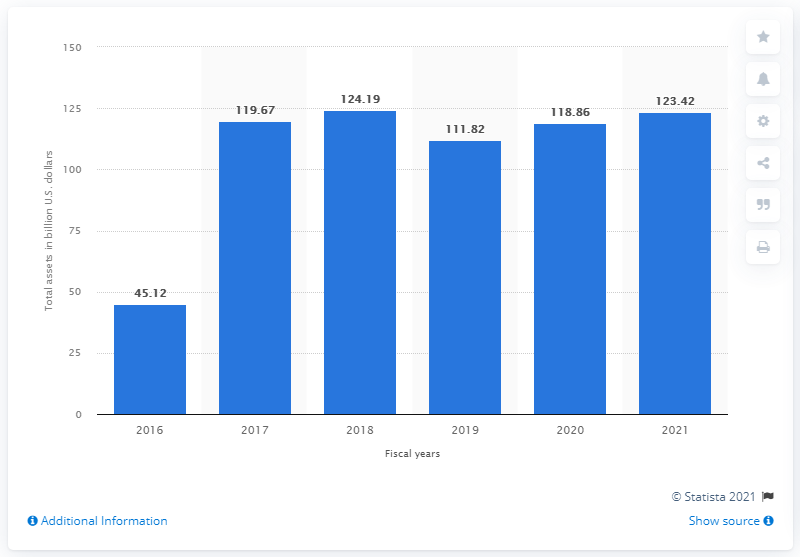Indicate a few pertinent items in this graphic. In the 2021 fiscal year, Dell Technologies' total assets were approximately 123.42. 